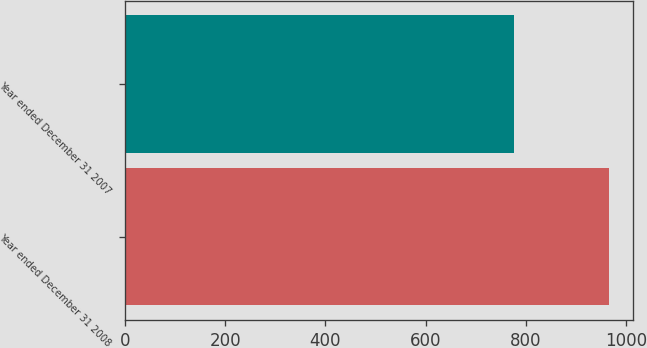Convert chart to OTSL. <chart><loc_0><loc_0><loc_500><loc_500><bar_chart><fcel>Year ended December 31 2008<fcel>Year ended December 31 2007<nl><fcel>966<fcel>776<nl></chart> 